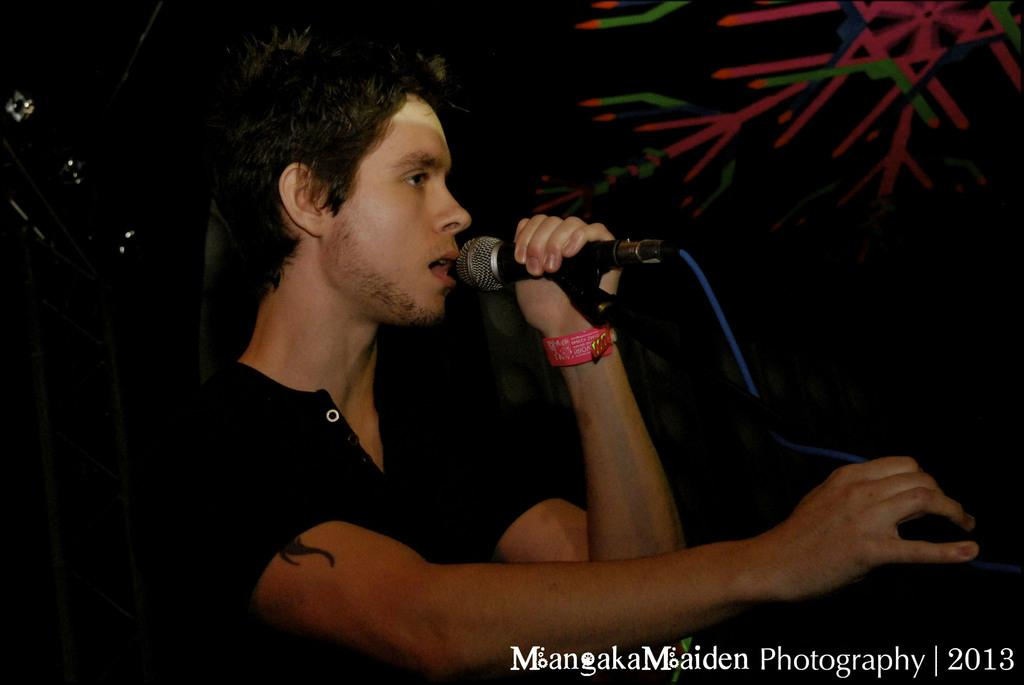What is the main subject of the image? There is a person in the image. What is the person holding in the image? The person is holding a microphone. What is the person wearing in the image? The person is wearing a black dress. What is the color of the background in the image? The background of the image is black in color. Can you tell me how many pets are visible in the image? There are no pets present in the image. What type of zephyr is blowing through the person's hair in the image? There is no zephyr present in the image; it is a still photograph. 